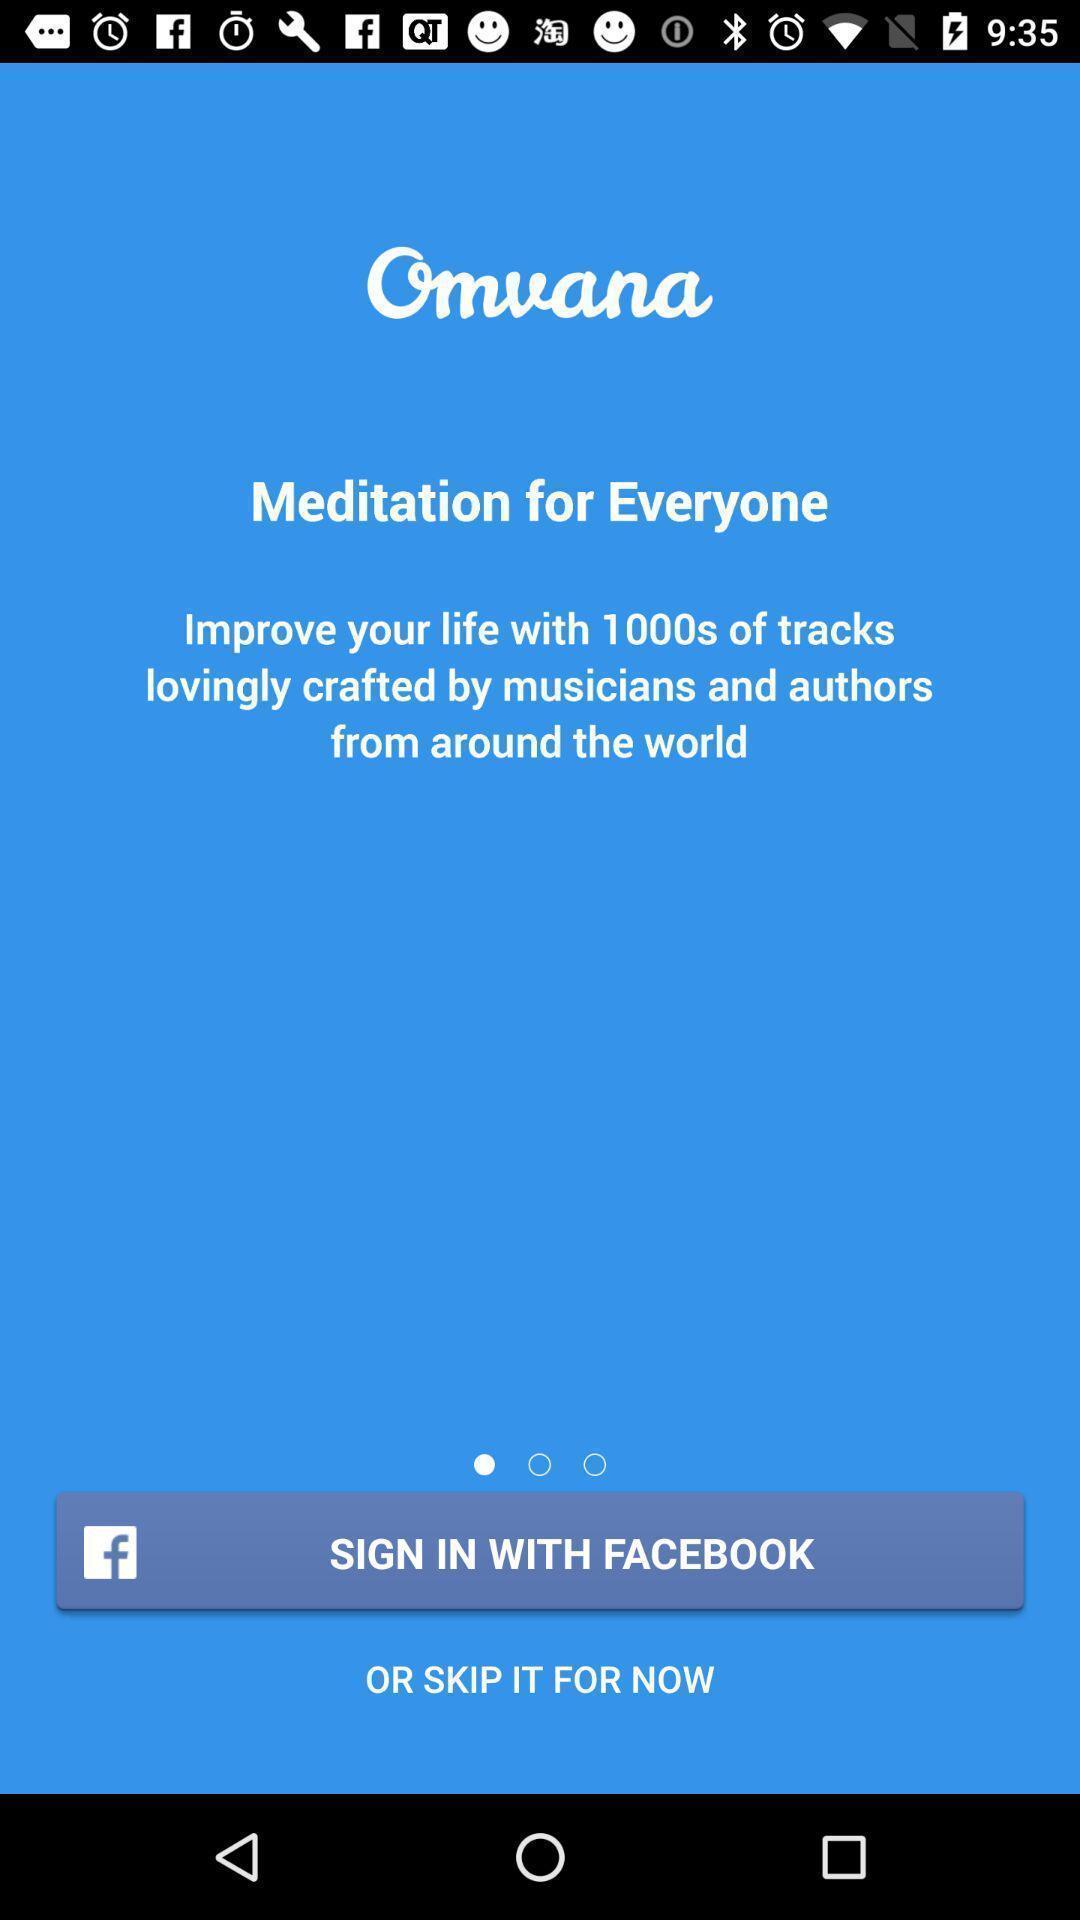What can you discern from this picture? Sign-in option is showing for a meditation app. 